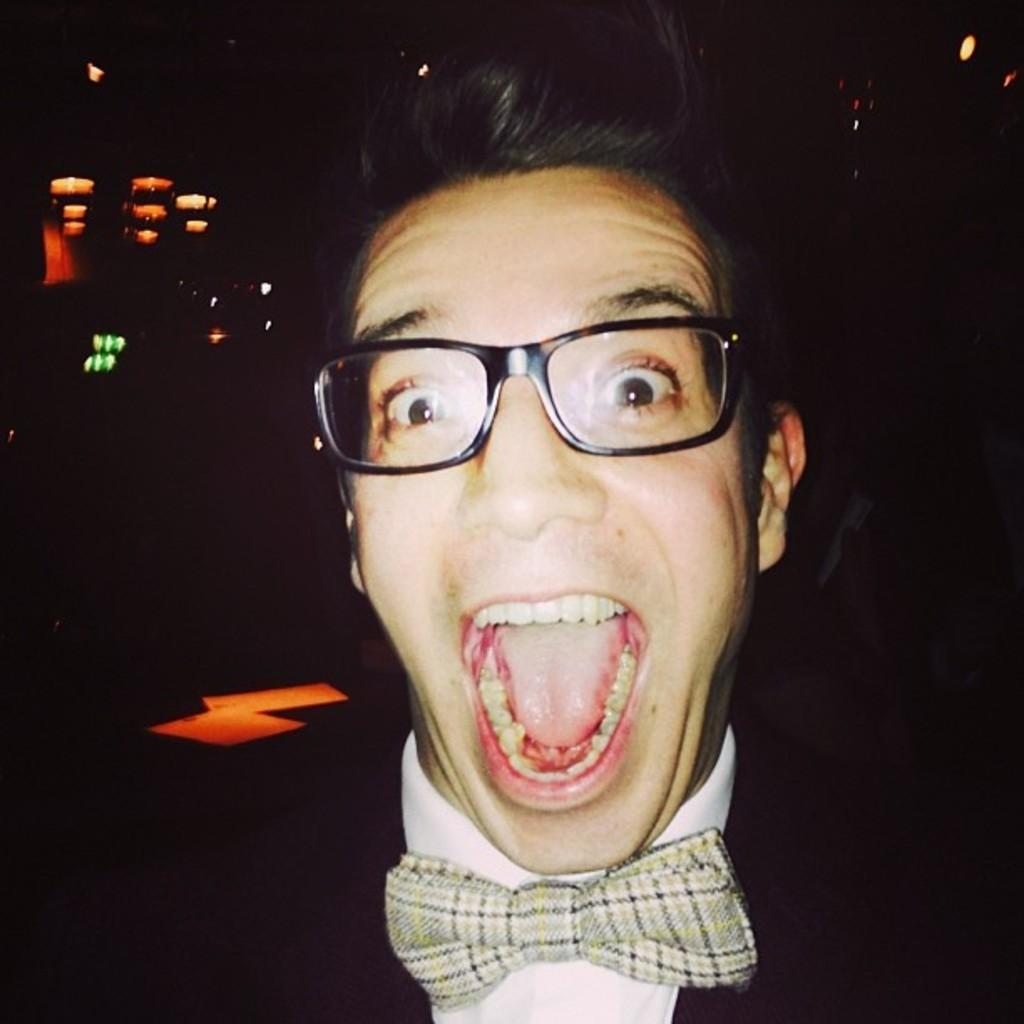Can you describe this image briefly? This is a dark image. In this picture we can see a person wearing spectacles. In the background we can see lights.   